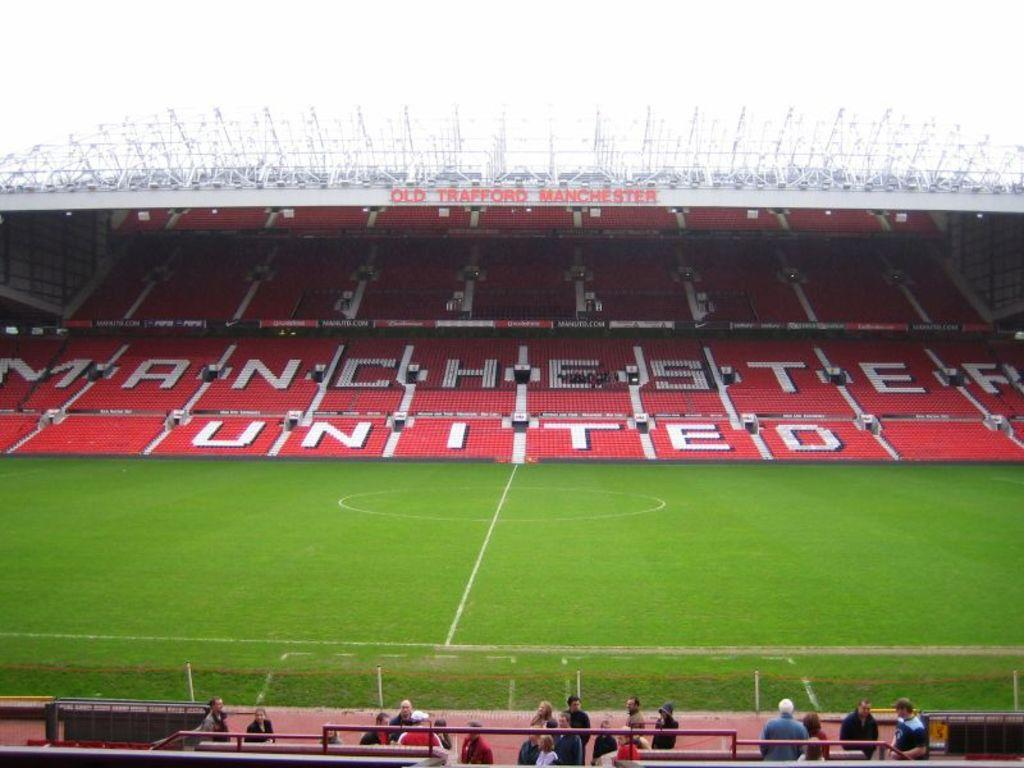What is the surface on which the people are standing in the image? The people are standing on the ground. What type of chairs can be seen in the image? There are red-colored sitting chairs in the image. What is the outcome of the battle that took place in the image? There is no battle present in the image, so it is not possible to determine the outcome. What does the ice cream taste like in the image? There is no ice cream present in the image, so it is not possible to determine its taste. 